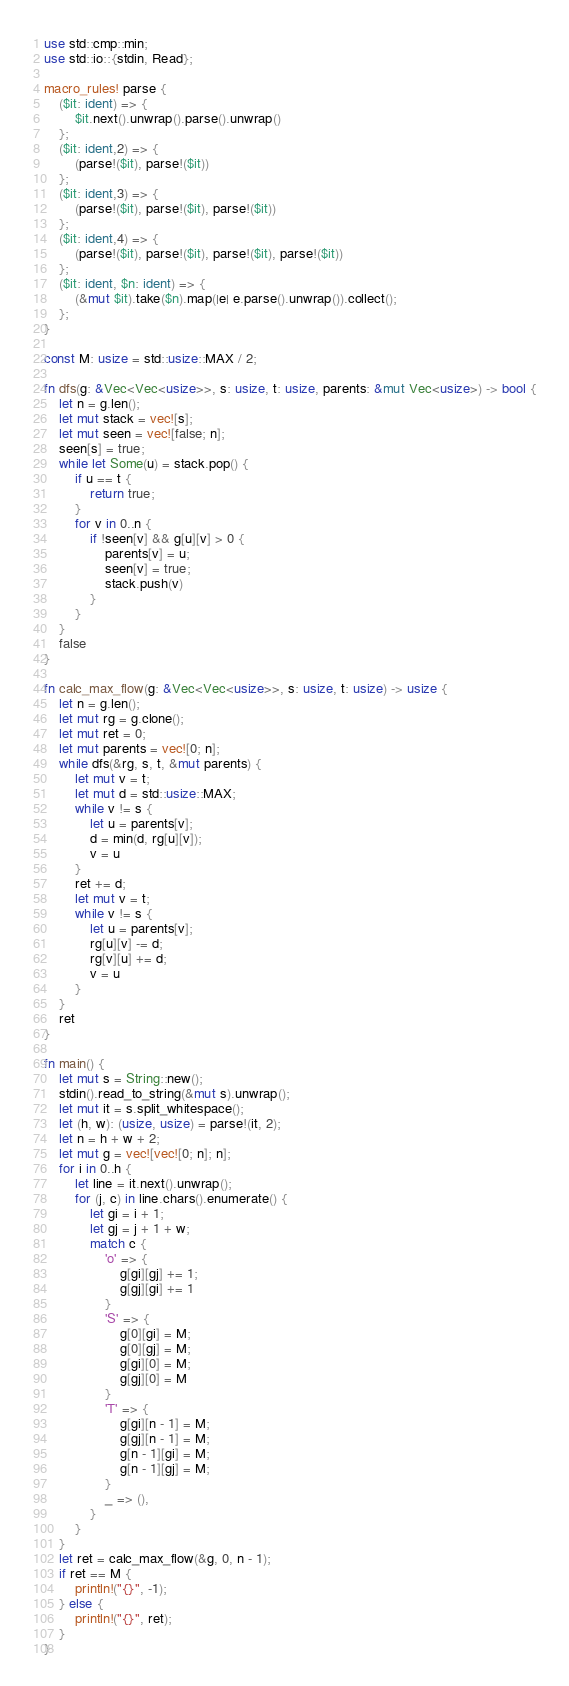Convert code to text. <code><loc_0><loc_0><loc_500><loc_500><_Rust_>use std::cmp::min;
use std::io::{stdin, Read};

macro_rules! parse {
    ($it: ident) => {
        $it.next().unwrap().parse().unwrap()
    };
    ($it: ident,2) => {
        (parse!($it), parse!($it))
    };
    ($it: ident,3) => {
        (parse!($it), parse!($it), parse!($it))
    };
    ($it: ident,4) => {
        (parse!($it), parse!($it), parse!($it), parse!($it))
    };
    ($it: ident, $n: ident) => {
        (&mut $it).take($n).map(|e| e.parse().unwrap()).collect();
    };
}

const M: usize = std::usize::MAX / 2;

fn dfs(g: &Vec<Vec<usize>>, s: usize, t: usize, parents: &mut Vec<usize>) -> bool {
    let n = g.len();
    let mut stack = vec![s];
    let mut seen = vec![false; n];
    seen[s] = true;
    while let Some(u) = stack.pop() {
        if u == t {
            return true;
        }
        for v in 0..n {
            if !seen[v] && g[u][v] > 0 {
                parents[v] = u;
                seen[v] = true;
                stack.push(v)
            }
        }
    }
    false
}

fn calc_max_flow(g: &Vec<Vec<usize>>, s: usize, t: usize) -> usize {
    let n = g.len();
    let mut rg = g.clone();
    let mut ret = 0;
    let mut parents = vec![0; n];
    while dfs(&rg, s, t, &mut parents) {
        let mut v = t;
        let mut d = std::usize::MAX;
        while v != s {
            let u = parents[v];
            d = min(d, rg[u][v]);
            v = u
        }
        ret += d;
        let mut v = t;
        while v != s {
            let u = parents[v];
            rg[u][v] -= d;
            rg[v][u] += d;
            v = u
        }
    }
    ret
}

fn main() {
    let mut s = String::new();
    stdin().read_to_string(&mut s).unwrap();
    let mut it = s.split_whitespace();
    let (h, w): (usize, usize) = parse!(it, 2);
    let n = h + w + 2;
    let mut g = vec![vec![0; n]; n];
    for i in 0..h {
        let line = it.next().unwrap();
        for (j, c) in line.chars().enumerate() {
            let gi = i + 1;
            let gj = j + 1 + w;
            match c {
                'o' => {
                    g[gi][gj] += 1;
                    g[gj][gi] += 1
                }
                'S' => {
                    g[0][gi] = M;
                    g[0][gj] = M;
                    g[gi][0] = M;
                    g[gj][0] = M
                }
                'T' => {
                    g[gi][n - 1] = M;
                    g[gj][n - 1] = M;
                    g[n - 1][gi] = M;
                    g[n - 1][gj] = M;
                }
                _ => (),
            }
        }
    }
    let ret = calc_max_flow(&g, 0, n - 1);
    if ret == M {
        println!("{}", -1);
    } else {
        println!("{}", ret);
    }
}
</code> 